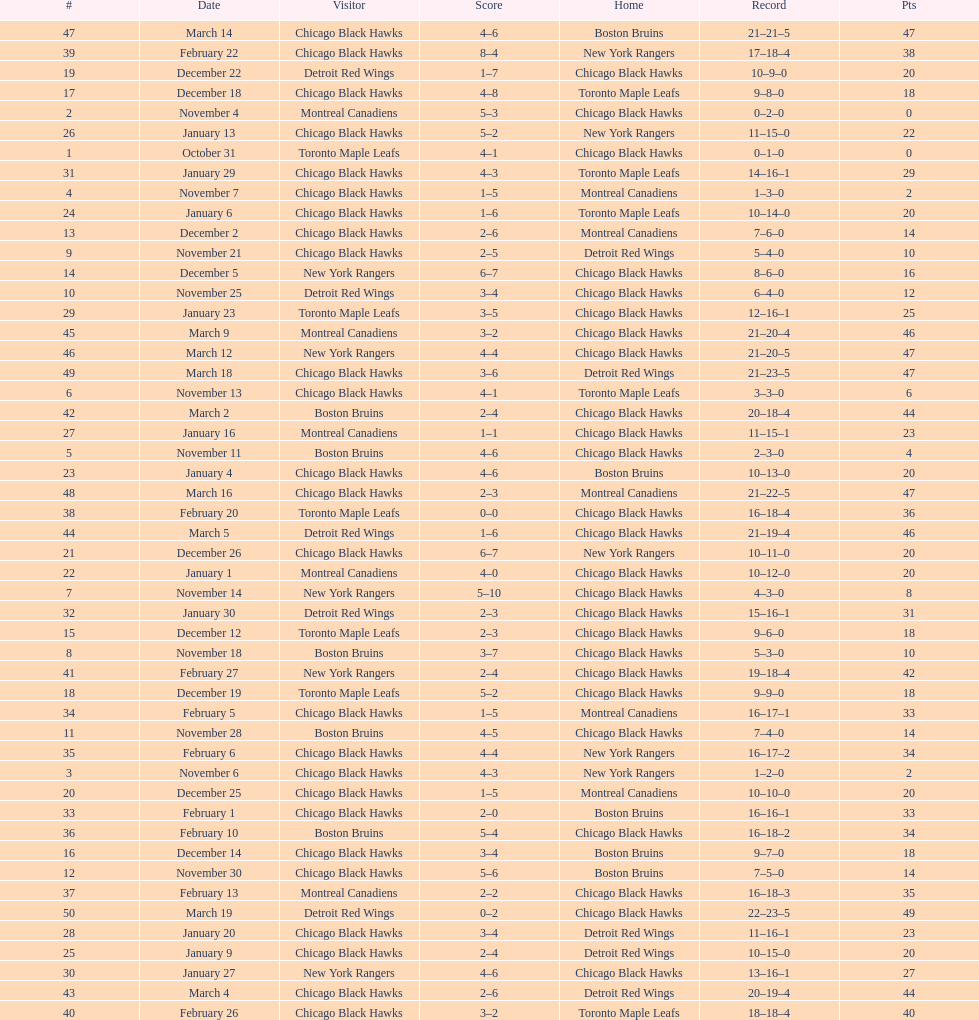Who was the next team that the boston bruins played after november 11? Chicago Black Hawks. 